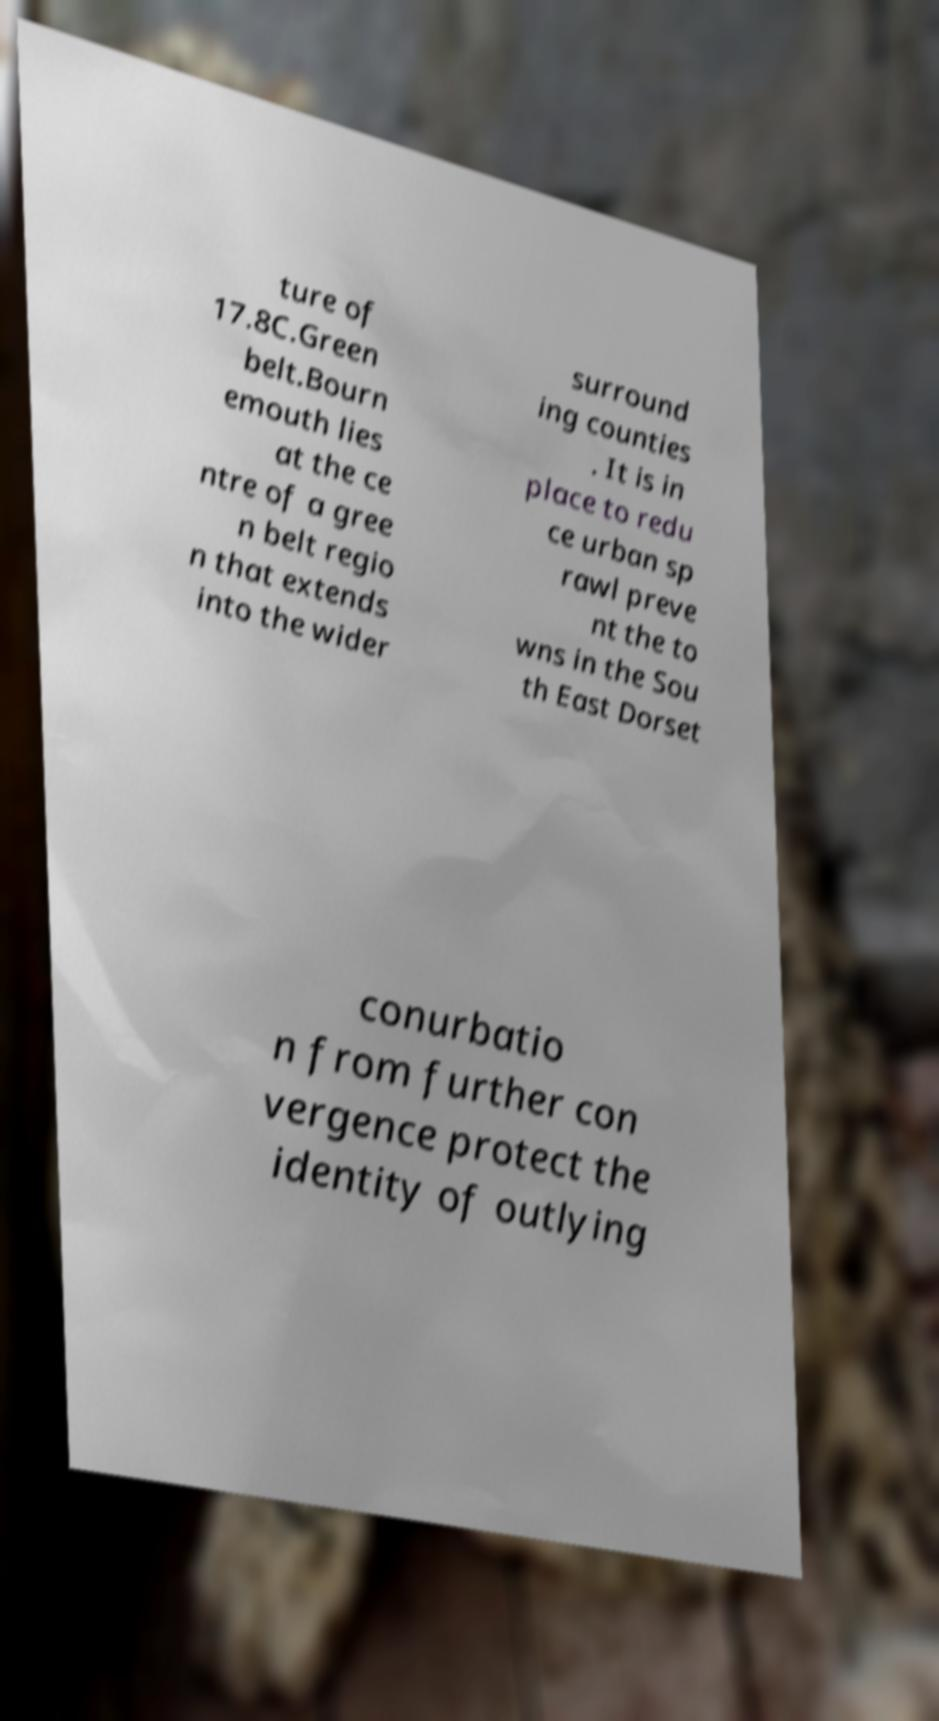For documentation purposes, I need the text within this image transcribed. Could you provide that? ture of 17.8C.Green belt.Bourn emouth lies at the ce ntre of a gree n belt regio n that extends into the wider surround ing counties . It is in place to redu ce urban sp rawl preve nt the to wns in the Sou th East Dorset conurbatio n from further con vergence protect the identity of outlying 